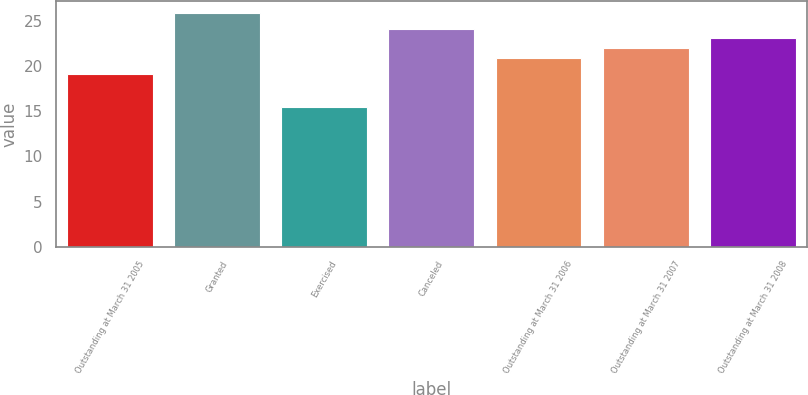Convert chart. <chart><loc_0><loc_0><loc_500><loc_500><bar_chart><fcel>Outstanding at March 31 2005<fcel>Granted<fcel>Exercised<fcel>Canceled<fcel>Outstanding at March 31 2006<fcel>Outstanding at March 31 2007<fcel>Outstanding at March 31 2008<nl><fcel>19.19<fcel>25.91<fcel>15.46<fcel>24.19<fcel>20.97<fcel>22.02<fcel>23.14<nl></chart> 